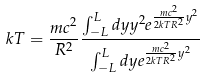Convert formula to latex. <formula><loc_0><loc_0><loc_500><loc_500>k T = \frac { m c ^ { 2 } } { R ^ { 2 } } \frac { \int _ { - L } ^ { L } d y y ^ { 2 } e ^ { \frac { m c ^ { 2 } } { 2 k T R ^ { 2 } } y ^ { 2 } } } { \int _ { - L } ^ { L } d y e ^ { \frac { m c ^ { 2 } } { 2 k T R ^ { 2 } } y ^ { 2 } } }</formula> 